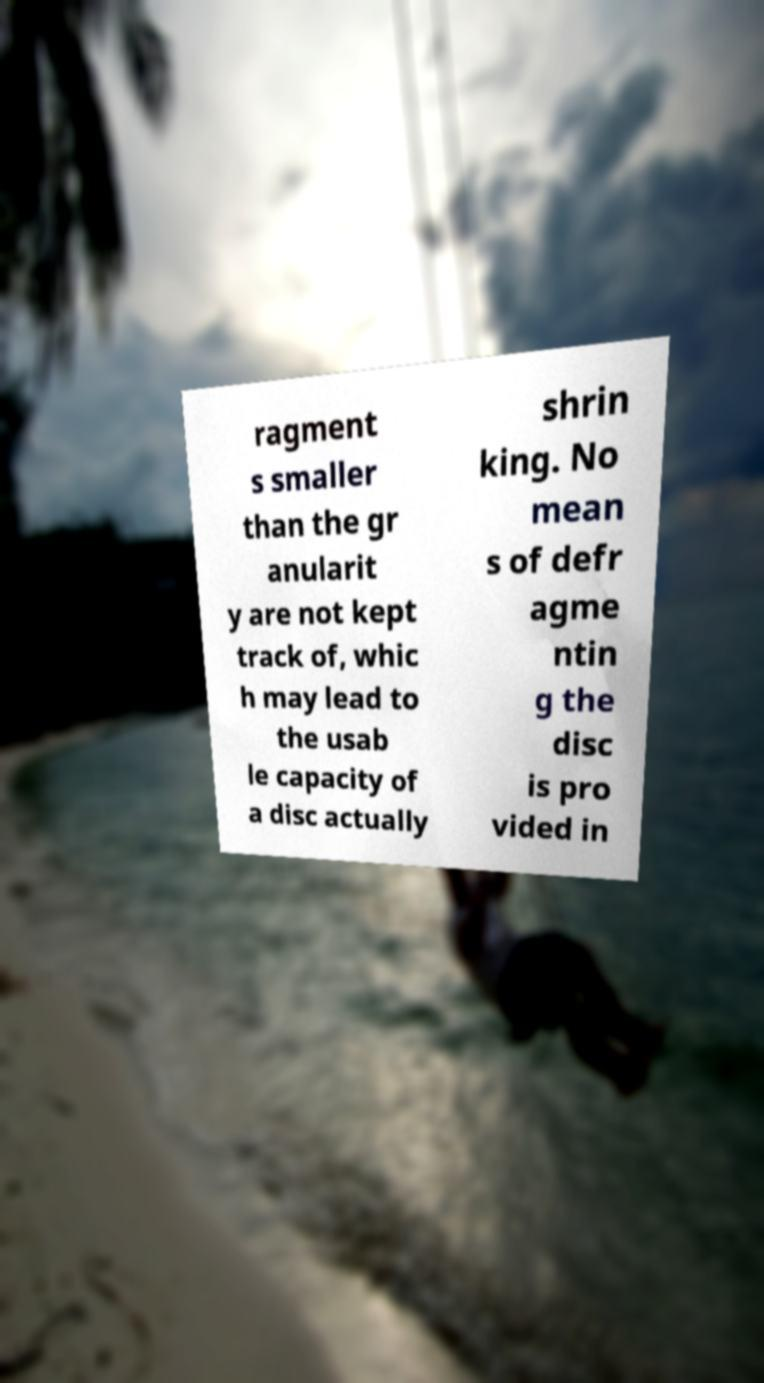Can you accurately transcribe the text from the provided image for me? ragment s smaller than the gr anularit y are not kept track of, whic h may lead to the usab le capacity of a disc actually shrin king. No mean s of defr agme ntin g the disc is pro vided in 